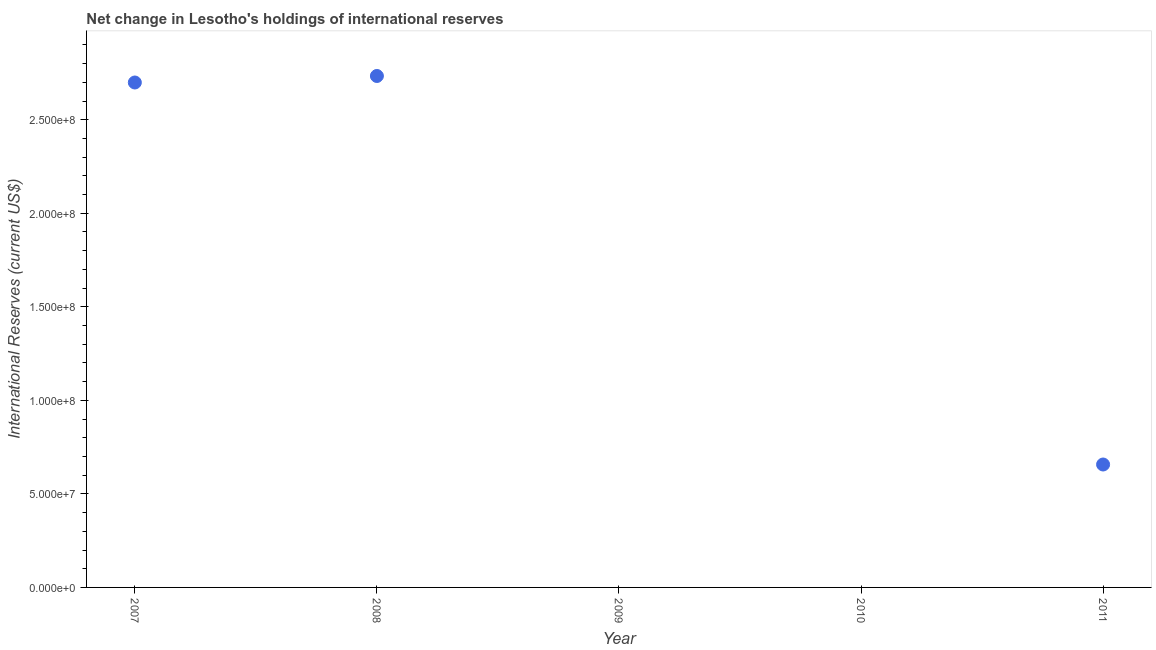Across all years, what is the maximum reserves and related items?
Your answer should be very brief. 2.73e+08. Across all years, what is the minimum reserves and related items?
Offer a very short reply. 0. What is the sum of the reserves and related items?
Give a very brief answer. 6.09e+08. What is the difference between the reserves and related items in 2008 and 2011?
Make the answer very short. 2.08e+08. What is the average reserves and related items per year?
Your answer should be compact. 1.22e+08. What is the median reserves and related items?
Your response must be concise. 6.57e+07. In how many years, is the reserves and related items greater than 210000000 US$?
Keep it short and to the point. 2. What is the difference between the highest and the second highest reserves and related items?
Keep it short and to the point. 3.48e+06. What is the difference between the highest and the lowest reserves and related items?
Give a very brief answer. 2.73e+08. How many dotlines are there?
Provide a succinct answer. 1. What is the difference between two consecutive major ticks on the Y-axis?
Give a very brief answer. 5.00e+07. Are the values on the major ticks of Y-axis written in scientific E-notation?
Provide a succinct answer. Yes. Does the graph contain any zero values?
Offer a terse response. Yes. What is the title of the graph?
Provide a short and direct response. Net change in Lesotho's holdings of international reserves. What is the label or title of the X-axis?
Make the answer very short. Year. What is the label or title of the Y-axis?
Give a very brief answer. International Reserves (current US$). What is the International Reserves (current US$) in 2007?
Your answer should be compact. 2.70e+08. What is the International Reserves (current US$) in 2008?
Give a very brief answer. 2.73e+08. What is the International Reserves (current US$) in 2009?
Offer a terse response. 0. What is the International Reserves (current US$) in 2010?
Make the answer very short. 0. What is the International Reserves (current US$) in 2011?
Keep it short and to the point. 6.57e+07. What is the difference between the International Reserves (current US$) in 2007 and 2008?
Ensure brevity in your answer.  -3.48e+06. What is the difference between the International Reserves (current US$) in 2007 and 2011?
Ensure brevity in your answer.  2.04e+08. What is the difference between the International Reserves (current US$) in 2008 and 2011?
Give a very brief answer. 2.08e+08. What is the ratio of the International Reserves (current US$) in 2007 to that in 2008?
Ensure brevity in your answer.  0.99. What is the ratio of the International Reserves (current US$) in 2007 to that in 2011?
Offer a very short reply. 4.11. What is the ratio of the International Reserves (current US$) in 2008 to that in 2011?
Ensure brevity in your answer.  4.16. 